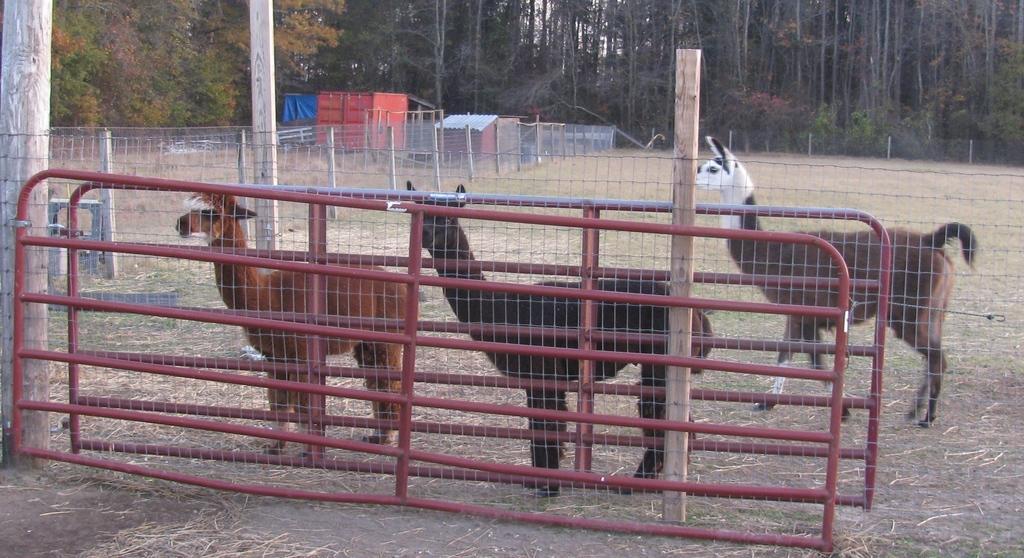Can you describe this image briefly? As we can see in the image there is fence, animals, container, house and trees. 